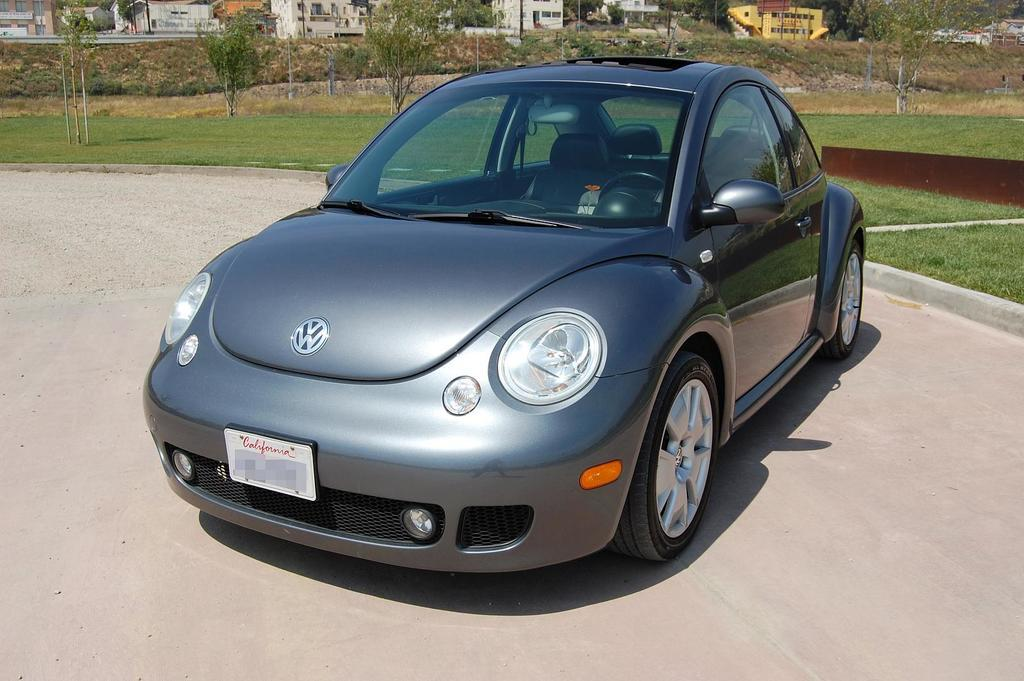What type of motor vehicle is on the floor in the image? The facts do not specify the type of motor vehicle, only that there is one on the floor. What can be seen growing in the image? Grass is visible in the image. What type of vegetation is present in the image? Trees are present in the image. What structures can be seen in the image? Poles and buildings are visible in the image. What man-made objects are present in the image? Pipelines are present in the image. Can you tell me how many goldfish are swimming in the image? There are no goldfish present in the image. What type of rice is being cooked in the image? There is no rice being cooked in the image. 